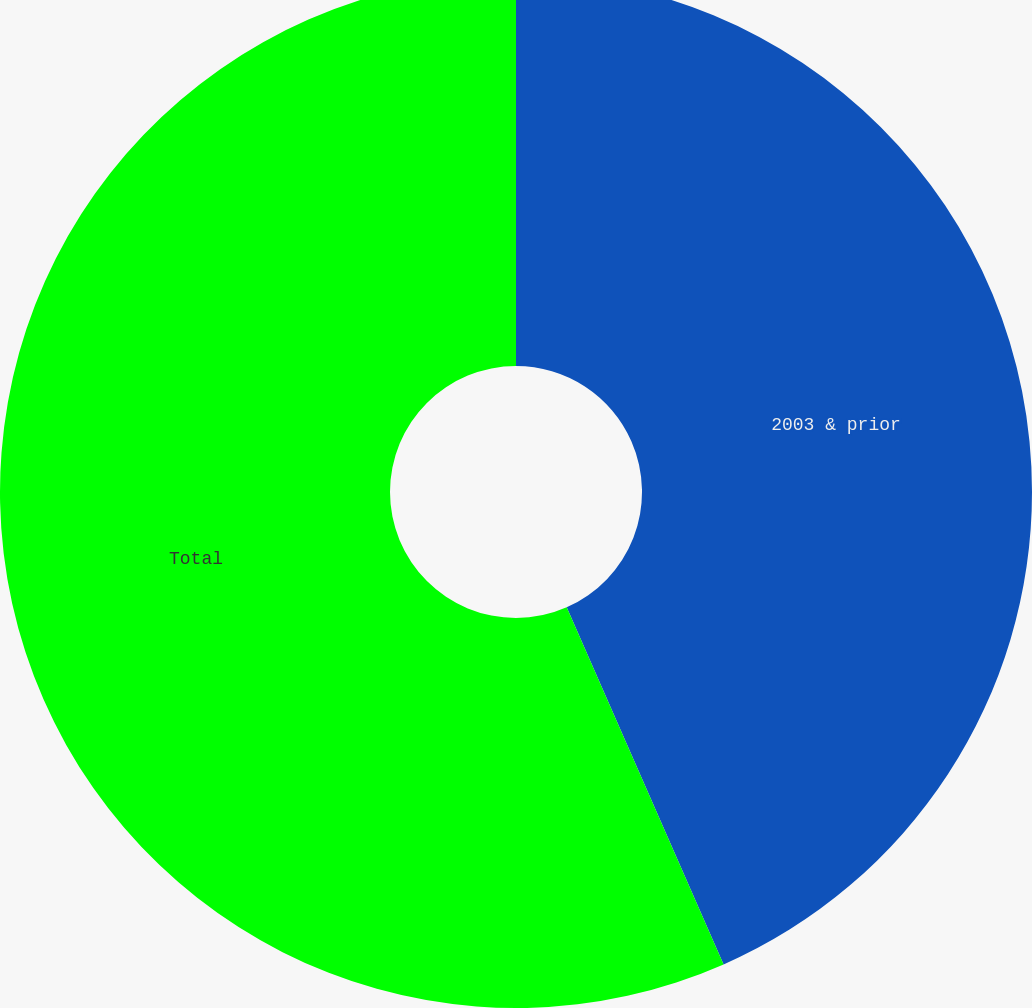<chart> <loc_0><loc_0><loc_500><loc_500><pie_chart><fcel>2003 & prior<fcel>Total<nl><fcel>43.41%<fcel>56.59%<nl></chart> 